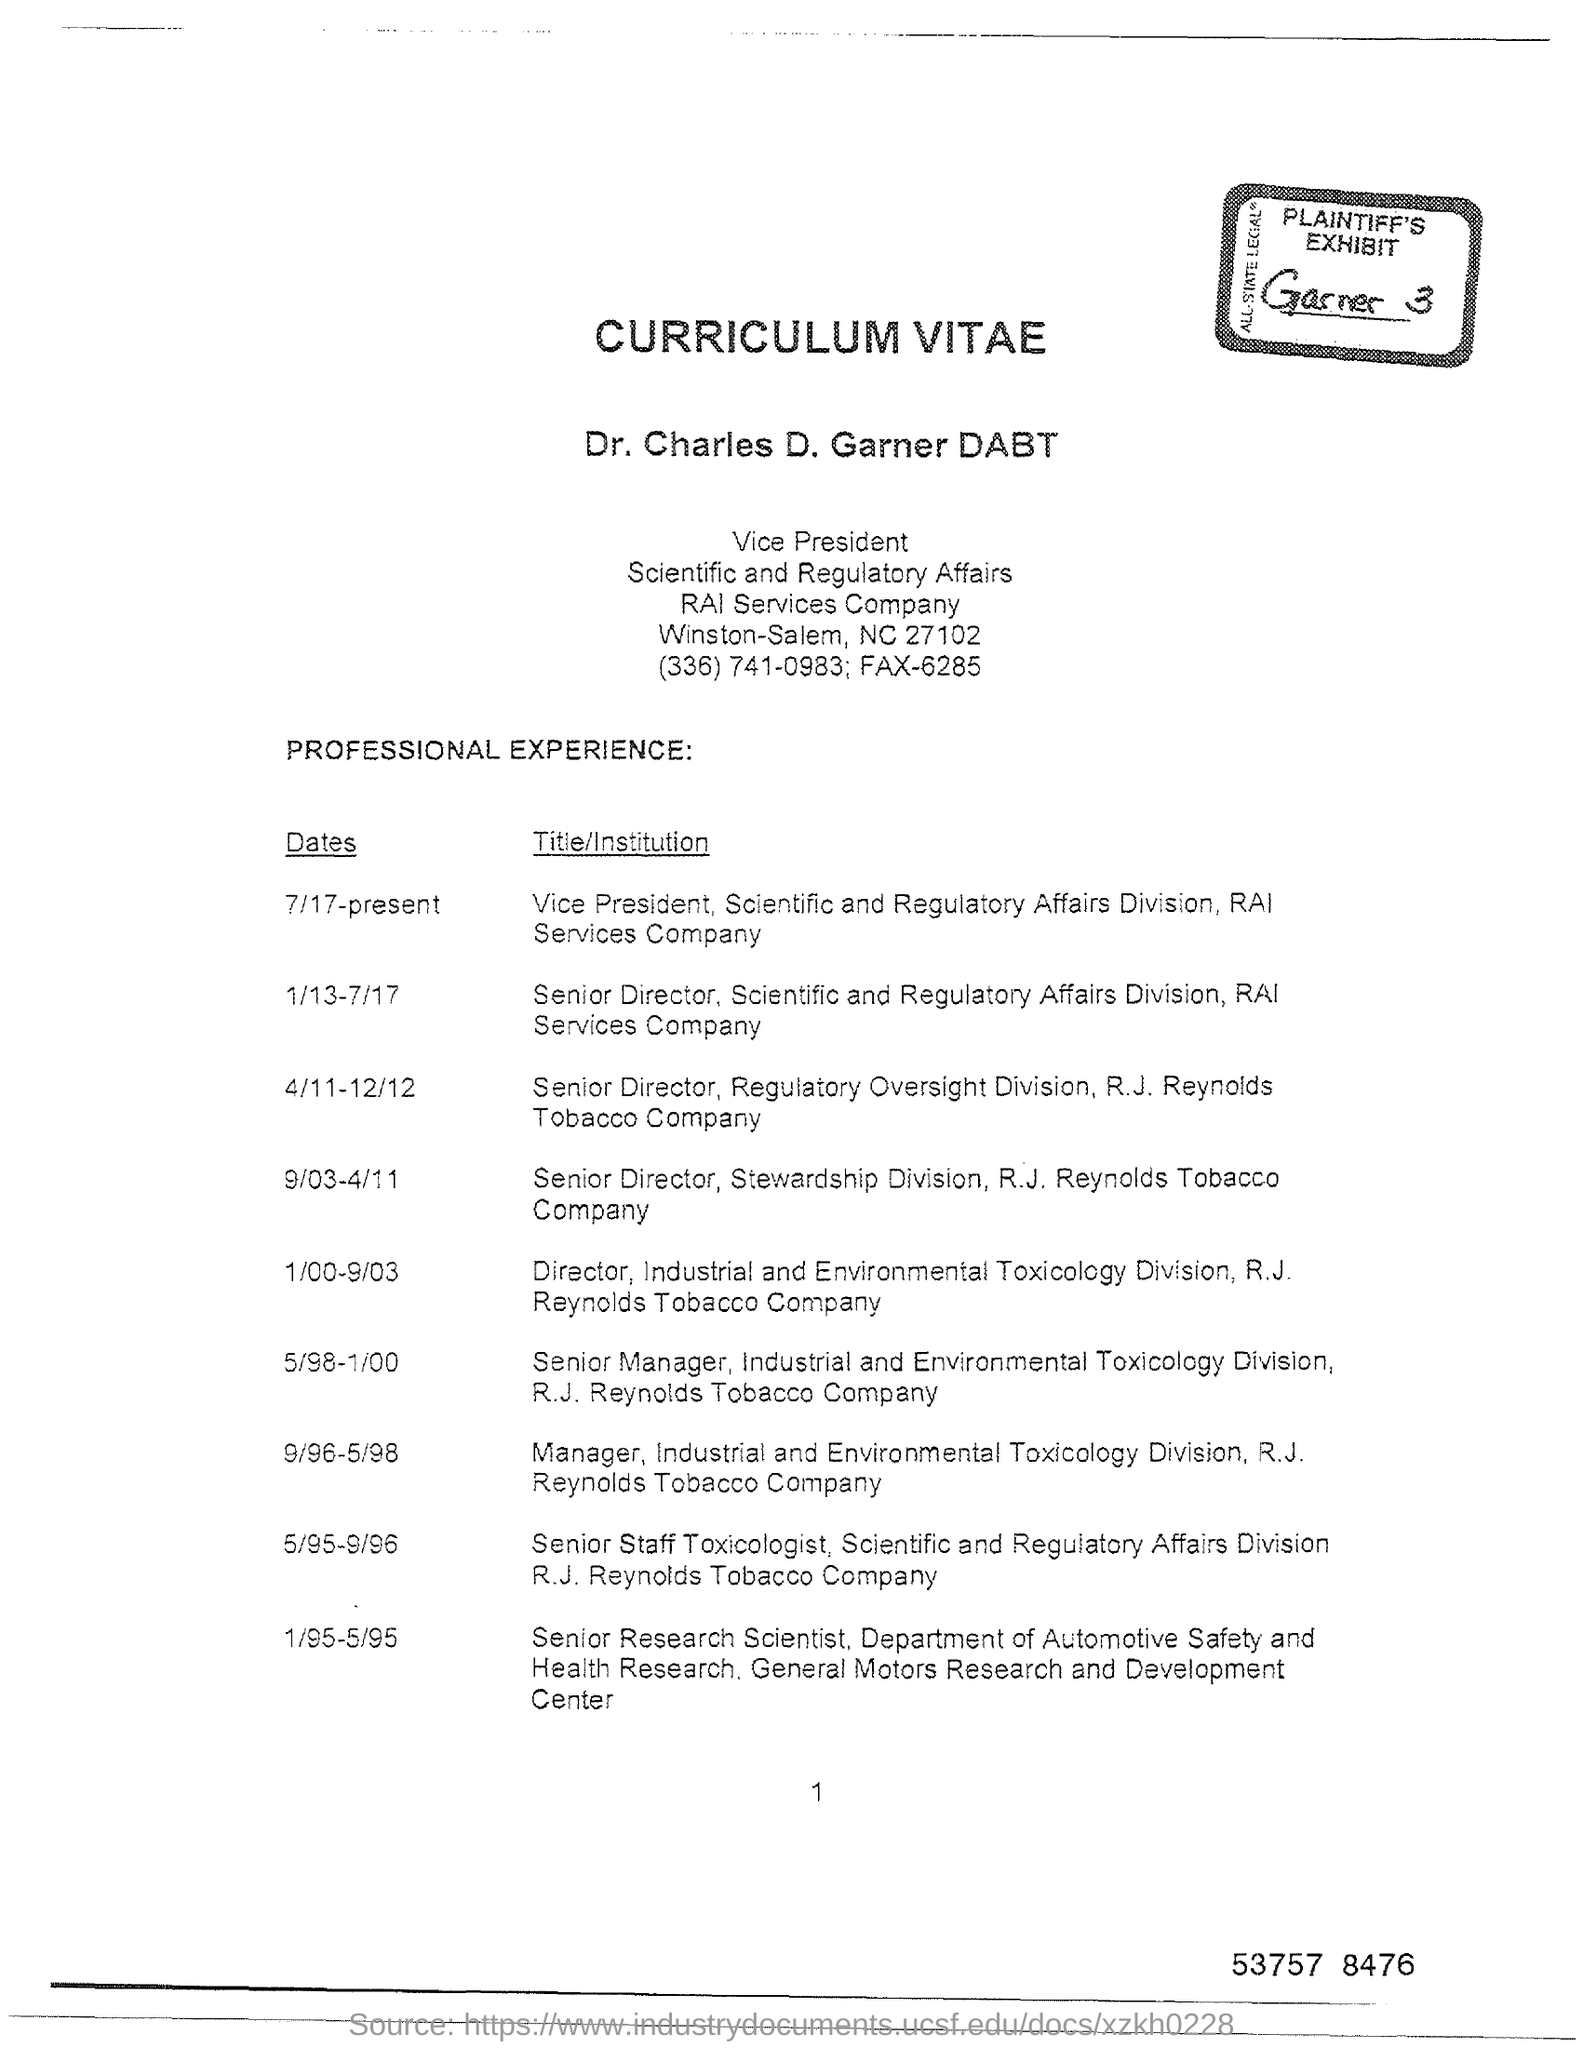List a handful of essential elements in this visual. Dr. Charles D. Garner is the vice president of RAI Services Company. 